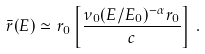Convert formula to latex. <formula><loc_0><loc_0><loc_500><loc_500>\bar { r } ( E ) \simeq r _ { 0 } \left [ \frac { \nu _ { 0 } ( E / E _ { 0 } ) ^ { - \alpha } r _ { 0 } } { c } \right ] \, .</formula> 